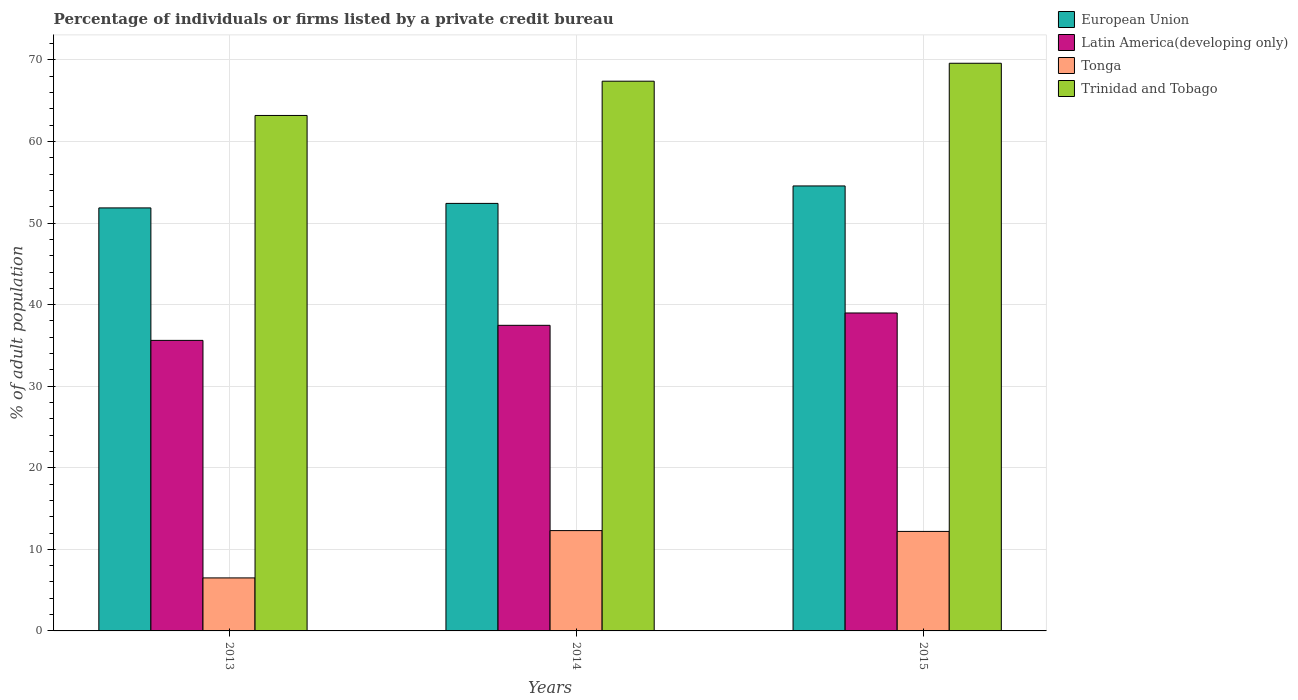Are the number of bars on each tick of the X-axis equal?
Offer a very short reply. Yes. What is the label of the 1st group of bars from the left?
Provide a succinct answer. 2013. In how many cases, is the number of bars for a given year not equal to the number of legend labels?
Provide a succinct answer. 0. What is the percentage of population listed by a private credit bureau in European Union in 2014?
Your answer should be very brief. 52.42. Across all years, what is the minimum percentage of population listed by a private credit bureau in European Union?
Your response must be concise. 51.86. In which year was the percentage of population listed by a private credit bureau in Latin America(developing only) maximum?
Your answer should be very brief. 2015. In which year was the percentage of population listed by a private credit bureau in Tonga minimum?
Your response must be concise. 2013. What is the total percentage of population listed by a private credit bureau in Trinidad and Tobago in the graph?
Your answer should be compact. 200.2. What is the difference between the percentage of population listed by a private credit bureau in Trinidad and Tobago in 2013 and that in 2015?
Give a very brief answer. -6.4. What is the difference between the percentage of population listed by a private credit bureau in Trinidad and Tobago in 2014 and the percentage of population listed by a private credit bureau in European Union in 2013?
Your answer should be very brief. 15.54. What is the average percentage of population listed by a private credit bureau in Tonga per year?
Keep it short and to the point. 10.33. In the year 2015, what is the difference between the percentage of population listed by a private credit bureau in Latin America(developing only) and percentage of population listed by a private credit bureau in Trinidad and Tobago?
Ensure brevity in your answer.  -30.62. What is the ratio of the percentage of population listed by a private credit bureau in European Union in 2013 to that in 2014?
Offer a terse response. 0.99. Is the percentage of population listed by a private credit bureau in Latin America(developing only) in 2013 less than that in 2015?
Offer a very short reply. Yes. What is the difference between the highest and the second highest percentage of population listed by a private credit bureau in Tonga?
Offer a very short reply. 0.1. What is the difference between the highest and the lowest percentage of population listed by a private credit bureau in Tonga?
Make the answer very short. 5.8. In how many years, is the percentage of population listed by a private credit bureau in Trinidad and Tobago greater than the average percentage of population listed by a private credit bureau in Trinidad and Tobago taken over all years?
Give a very brief answer. 2. Is the sum of the percentage of population listed by a private credit bureau in Trinidad and Tobago in 2014 and 2015 greater than the maximum percentage of population listed by a private credit bureau in Tonga across all years?
Your answer should be very brief. Yes. Is it the case that in every year, the sum of the percentage of population listed by a private credit bureau in Latin America(developing only) and percentage of population listed by a private credit bureau in Trinidad and Tobago is greater than the sum of percentage of population listed by a private credit bureau in Tonga and percentage of population listed by a private credit bureau in European Union?
Give a very brief answer. No. What does the 4th bar from the left in 2014 represents?
Keep it short and to the point. Trinidad and Tobago. What does the 4th bar from the right in 2015 represents?
Your answer should be compact. European Union. Is it the case that in every year, the sum of the percentage of population listed by a private credit bureau in Latin America(developing only) and percentage of population listed by a private credit bureau in Tonga is greater than the percentage of population listed by a private credit bureau in Trinidad and Tobago?
Your response must be concise. No. What is the title of the graph?
Keep it short and to the point. Percentage of individuals or firms listed by a private credit bureau. Does "Thailand" appear as one of the legend labels in the graph?
Make the answer very short. No. What is the label or title of the X-axis?
Ensure brevity in your answer.  Years. What is the label or title of the Y-axis?
Ensure brevity in your answer.  % of adult population. What is the % of adult population in European Union in 2013?
Keep it short and to the point. 51.86. What is the % of adult population in Latin America(developing only) in 2013?
Your response must be concise. 35.62. What is the % of adult population of Trinidad and Tobago in 2013?
Ensure brevity in your answer.  63.2. What is the % of adult population in European Union in 2014?
Offer a terse response. 52.42. What is the % of adult population of Latin America(developing only) in 2014?
Offer a very short reply. 37.47. What is the % of adult population in Tonga in 2014?
Your answer should be compact. 12.3. What is the % of adult population of Trinidad and Tobago in 2014?
Offer a very short reply. 67.4. What is the % of adult population in European Union in 2015?
Your response must be concise. 54.56. What is the % of adult population in Latin America(developing only) in 2015?
Your response must be concise. 38.98. What is the % of adult population of Trinidad and Tobago in 2015?
Make the answer very short. 69.6. Across all years, what is the maximum % of adult population of European Union?
Offer a very short reply. 54.56. Across all years, what is the maximum % of adult population of Latin America(developing only)?
Give a very brief answer. 38.98. Across all years, what is the maximum % of adult population of Tonga?
Make the answer very short. 12.3. Across all years, what is the maximum % of adult population of Trinidad and Tobago?
Your answer should be very brief. 69.6. Across all years, what is the minimum % of adult population of European Union?
Make the answer very short. 51.86. Across all years, what is the minimum % of adult population in Latin America(developing only)?
Provide a succinct answer. 35.62. Across all years, what is the minimum % of adult population in Trinidad and Tobago?
Offer a terse response. 63.2. What is the total % of adult population in European Union in the graph?
Provide a short and direct response. 158.84. What is the total % of adult population in Latin America(developing only) in the graph?
Your response must be concise. 112.07. What is the total % of adult population of Trinidad and Tobago in the graph?
Offer a terse response. 200.2. What is the difference between the % of adult population in European Union in 2013 and that in 2014?
Your response must be concise. -0.55. What is the difference between the % of adult population of Latin America(developing only) in 2013 and that in 2014?
Your response must be concise. -1.85. What is the difference between the % of adult population of Tonga in 2013 and that in 2014?
Your response must be concise. -5.8. What is the difference between the % of adult population in European Union in 2013 and that in 2015?
Make the answer very short. -2.69. What is the difference between the % of adult population in Latin America(developing only) in 2013 and that in 2015?
Give a very brief answer. -3.36. What is the difference between the % of adult population in Tonga in 2013 and that in 2015?
Ensure brevity in your answer.  -5.7. What is the difference between the % of adult population in European Union in 2014 and that in 2015?
Your answer should be very brief. -2.14. What is the difference between the % of adult population of Latin America(developing only) in 2014 and that in 2015?
Your answer should be compact. -1.51. What is the difference between the % of adult population in Trinidad and Tobago in 2014 and that in 2015?
Make the answer very short. -2.2. What is the difference between the % of adult population in European Union in 2013 and the % of adult population in Latin America(developing only) in 2014?
Provide a short and direct response. 14.39. What is the difference between the % of adult population in European Union in 2013 and the % of adult population in Tonga in 2014?
Your response must be concise. 39.56. What is the difference between the % of adult population in European Union in 2013 and the % of adult population in Trinidad and Tobago in 2014?
Give a very brief answer. -15.54. What is the difference between the % of adult population of Latin America(developing only) in 2013 and the % of adult population of Tonga in 2014?
Provide a succinct answer. 23.32. What is the difference between the % of adult population of Latin America(developing only) in 2013 and the % of adult population of Trinidad and Tobago in 2014?
Your answer should be compact. -31.78. What is the difference between the % of adult population in Tonga in 2013 and the % of adult population in Trinidad and Tobago in 2014?
Offer a terse response. -60.9. What is the difference between the % of adult population in European Union in 2013 and the % of adult population in Latin America(developing only) in 2015?
Provide a short and direct response. 12.88. What is the difference between the % of adult population in European Union in 2013 and the % of adult population in Tonga in 2015?
Provide a short and direct response. 39.66. What is the difference between the % of adult population in European Union in 2013 and the % of adult population in Trinidad and Tobago in 2015?
Offer a very short reply. -17.74. What is the difference between the % of adult population in Latin America(developing only) in 2013 and the % of adult population in Tonga in 2015?
Give a very brief answer. 23.42. What is the difference between the % of adult population of Latin America(developing only) in 2013 and the % of adult population of Trinidad and Tobago in 2015?
Keep it short and to the point. -33.98. What is the difference between the % of adult population in Tonga in 2013 and the % of adult population in Trinidad and Tobago in 2015?
Offer a very short reply. -63.1. What is the difference between the % of adult population in European Union in 2014 and the % of adult population in Latin America(developing only) in 2015?
Offer a terse response. 13.44. What is the difference between the % of adult population of European Union in 2014 and the % of adult population of Tonga in 2015?
Your answer should be compact. 40.22. What is the difference between the % of adult population in European Union in 2014 and the % of adult population in Trinidad and Tobago in 2015?
Keep it short and to the point. -17.18. What is the difference between the % of adult population in Latin America(developing only) in 2014 and the % of adult population in Tonga in 2015?
Give a very brief answer. 25.27. What is the difference between the % of adult population in Latin America(developing only) in 2014 and the % of adult population in Trinidad and Tobago in 2015?
Your answer should be very brief. -32.13. What is the difference between the % of adult population of Tonga in 2014 and the % of adult population of Trinidad and Tobago in 2015?
Your response must be concise. -57.3. What is the average % of adult population in European Union per year?
Keep it short and to the point. 52.95. What is the average % of adult population in Latin America(developing only) per year?
Your answer should be very brief. 37.36. What is the average % of adult population in Tonga per year?
Make the answer very short. 10.33. What is the average % of adult population in Trinidad and Tobago per year?
Offer a terse response. 66.73. In the year 2013, what is the difference between the % of adult population in European Union and % of adult population in Latin America(developing only)?
Your response must be concise. 16.24. In the year 2013, what is the difference between the % of adult population of European Union and % of adult population of Tonga?
Give a very brief answer. 45.36. In the year 2013, what is the difference between the % of adult population in European Union and % of adult population in Trinidad and Tobago?
Offer a very short reply. -11.34. In the year 2013, what is the difference between the % of adult population in Latin America(developing only) and % of adult population in Tonga?
Offer a very short reply. 29.12. In the year 2013, what is the difference between the % of adult population in Latin America(developing only) and % of adult population in Trinidad and Tobago?
Provide a short and direct response. -27.58. In the year 2013, what is the difference between the % of adult population in Tonga and % of adult population in Trinidad and Tobago?
Offer a terse response. -56.7. In the year 2014, what is the difference between the % of adult population in European Union and % of adult population in Latin America(developing only)?
Make the answer very short. 14.95. In the year 2014, what is the difference between the % of adult population in European Union and % of adult population in Tonga?
Offer a very short reply. 40.12. In the year 2014, what is the difference between the % of adult population of European Union and % of adult population of Trinidad and Tobago?
Make the answer very short. -14.98. In the year 2014, what is the difference between the % of adult population of Latin America(developing only) and % of adult population of Tonga?
Provide a succinct answer. 25.17. In the year 2014, what is the difference between the % of adult population in Latin America(developing only) and % of adult population in Trinidad and Tobago?
Ensure brevity in your answer.  -29.93. In the year 2014, what is the difference between the % of adult population of Tonga and % of adult population of Trinidad and Tobago?
Offer a very short reply. -55.1. In the year 2015, what is the difference between the % of adult population of European Union and % of adult population of Latin America(developing only)?
Offer a terse response. 15.57. In the year 2015, what is the difference between the % of adult population in European Union and % of adult population in Tonga?
Keep it short and to the point. 42.36. In the year 2015, what is the difference between the % of adult population in European Union and % of adult population in Trinidad and Tobago?
Give a very brief answer. -15.04. In the year 2015, what is the difference between the % of adult population in Latin America(developing only) and % of adult population in Tonga?
Give a very brief answer. 26.78. In the year 2015, what is the difference between the % of adult population in Latin America(developing only) and % of adult population in Trinidad and Tobago?
Keep it short and to the point. -30.62. In the year 2015, what is the difference between the % of adult population of Tonga and % of adult population of Trinidad and Tobago?
Your answer should be very brief. -57.4. What is the ratio of the % of adult population of European Union in 2013 to that in 2014?
Give a very brief answer. 0.99. What is the ratio of the % of adult population of Latin America(developing only) in 2013 to that in 2014?
Offer a very short reply. 0.95. What is the ratio of the % of adult population of Tonga in 2013 to that in 2014?
Provide a succinct answer. 0.53. What is the ratio of the % of adult population of Trinidad and Tobago in 2013 to that in 2014?
Provide a succinct answer. 0.94. What is the ratio of the % of adult population in European Union in 2013 to that in 2015?
Make the answer very short. 0.95. What is the ratio of the % of adult population of Latin America(developing only) in 2013 to that in 2015?
Offer a terse response. 0.91. What is the ratio of the % of adult population in Tonga in 2013 to that in 2015?
Offer a terse response. 0.53. What is the ratio of the % of adult population of Trinidad and Tobago in 2013 to that in 2015?
Your response must be concise. 0.91. What is the ratio of the % of adult population of European Union in 2014 to that in 2015?
Offer a terse response. 0.96. What is the ratio of the % of adult population in Latin America(developing only) in 2014 to that in 2015?
Offer a terse response. 0.96. What is the ratio of the % of adult population in Tonga in 2014 to that in 2015?
Offer a very short reply. 1.01. What is the ratio of the % of adult population in Trinidad and Tobago in 2014 to that in 2015?
Keep it short and to the point. 0.97. What is the difference between the highest and the second highest % of adult population in European Union?
Your response must be concise. 2.14. What is the difference between the highest and the second highest % of adult population of Latin America(developing only)?
Ensure brevity in your answer.  1.51. What is the difference between the highest and the second highest % of adult population in Tonga?
Your answer should be very brief. 0.1. What is the difference between the highest and the lowest % of adult population in European Union?
Provide a short and direct response. 2.69. What is the difference between the highest and the lowest % of adult population in Latin America(developing only)?
Ensure brevity in your answer.  3.36. What is the difference between the highest and the lowest % of adult population in Tonga?
Your answer should be very brief. 5.8. 